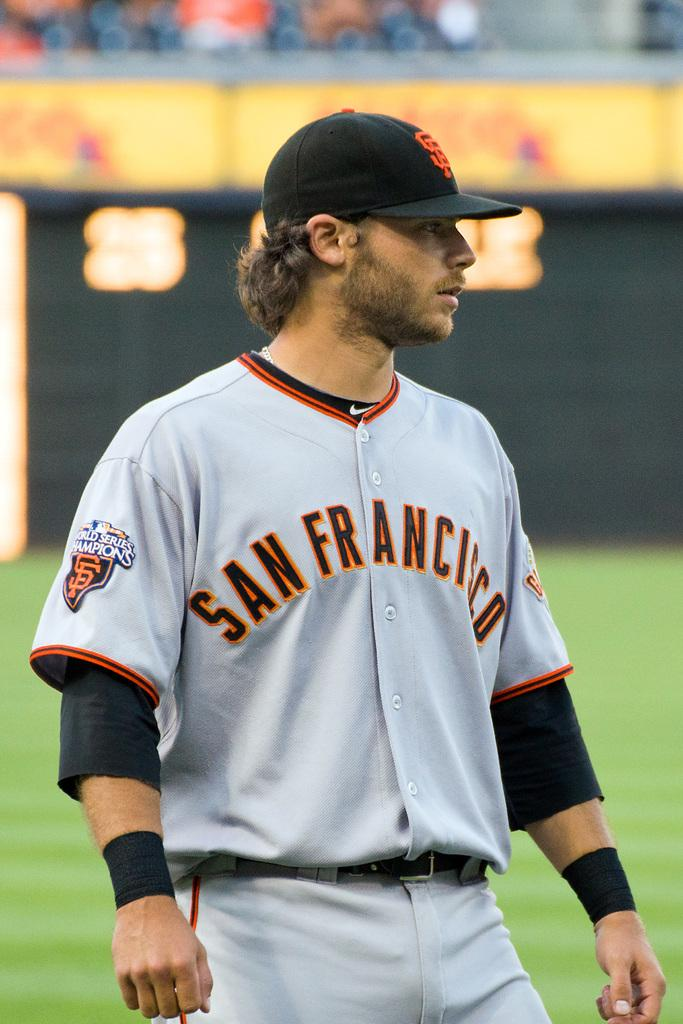Who is the person in the image? There is a man in the image. What is the man wearing on his head? The man is wearing a black cap. What is the man wearing as his primary clothing? The man is wearing a white dress. Can you describe the background of the image? The background of the image is blurred. What type of chain is the man holding in the image? There is no chain present in the image; the man is not holding anything. 